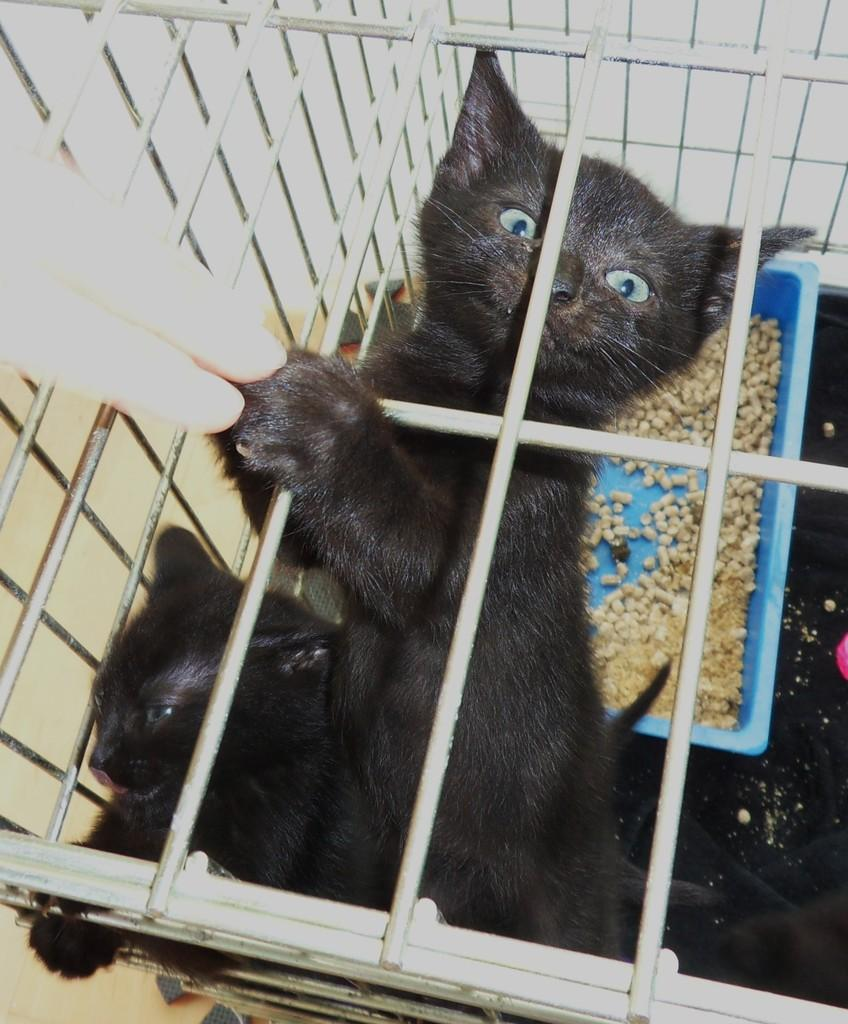What type of animals are present in the image? There are black color cats in the image. What object can be seen in the image that might be used for holding or serving items? There is a tray in the image. What part of a human body is visible in the image? A human hand is visible in the image. What type of food can be seen in the image? There are nuts in the image. How many toes can be seen on the cats' feet in the image? The image does not show the cats' feet, so it is not possible to determine the number of toes. 